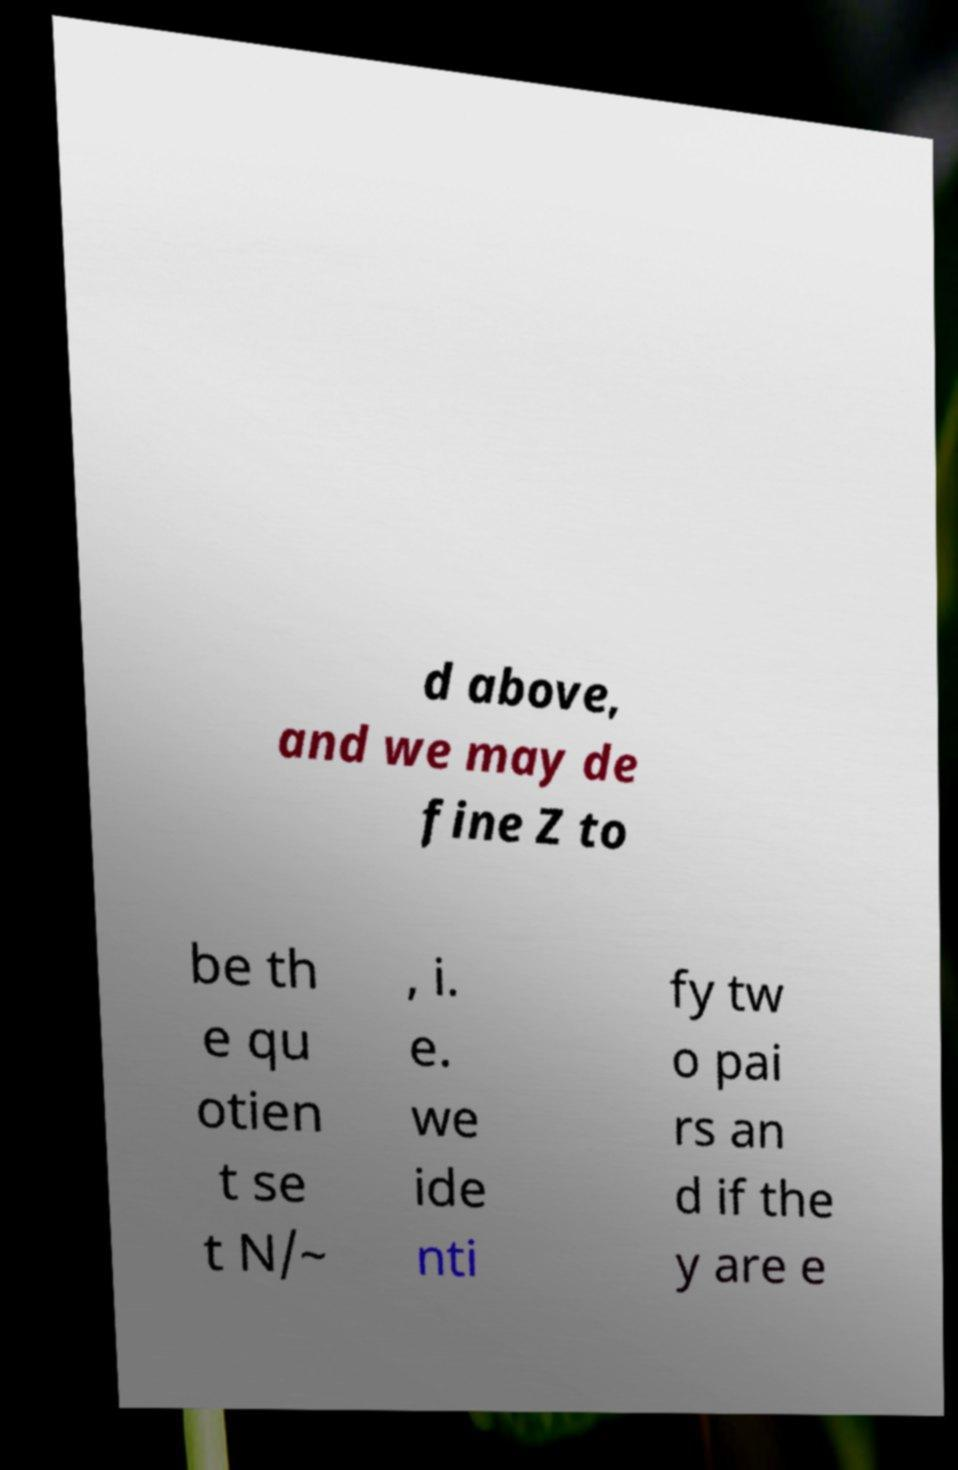Could you assist in decoding the text presented in this image and type it out clearly? d above, and we may de fine Z to be th e qu otien t se t N/~ , i. e. we ide nti fy tw o pai rs an d if the y are e 